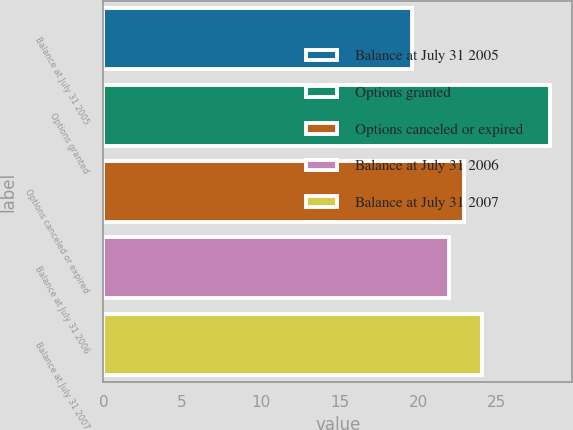<chart> <loc_0><loc_0><loc_500><loc_500><bar_chart><fcel>Balance at July 31 2005<fcel>Options granted<fcel>Options canceled or expired<fcel>Balance at July 31 2006<fcel>Balance at July 31 2007<nl><fcel>19.59<fcel>28.37<fcel>22.93<fcel>21.93<fcel>24.05<nl></chart> 